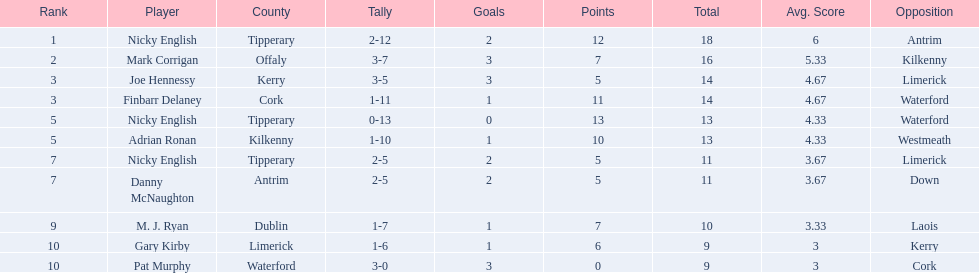Which of the following players were ranked in the bottom 5? Nicky English, Danny McNaughton, M. J. Ryan, Gary Kirby, Pat Murphy. Of these, whose tallies were not 2-5? M. J. Ryan, Gary Kirby, Pat Murphy. From the above three, which one scored more than 9 total points? M. J. Ryan. 